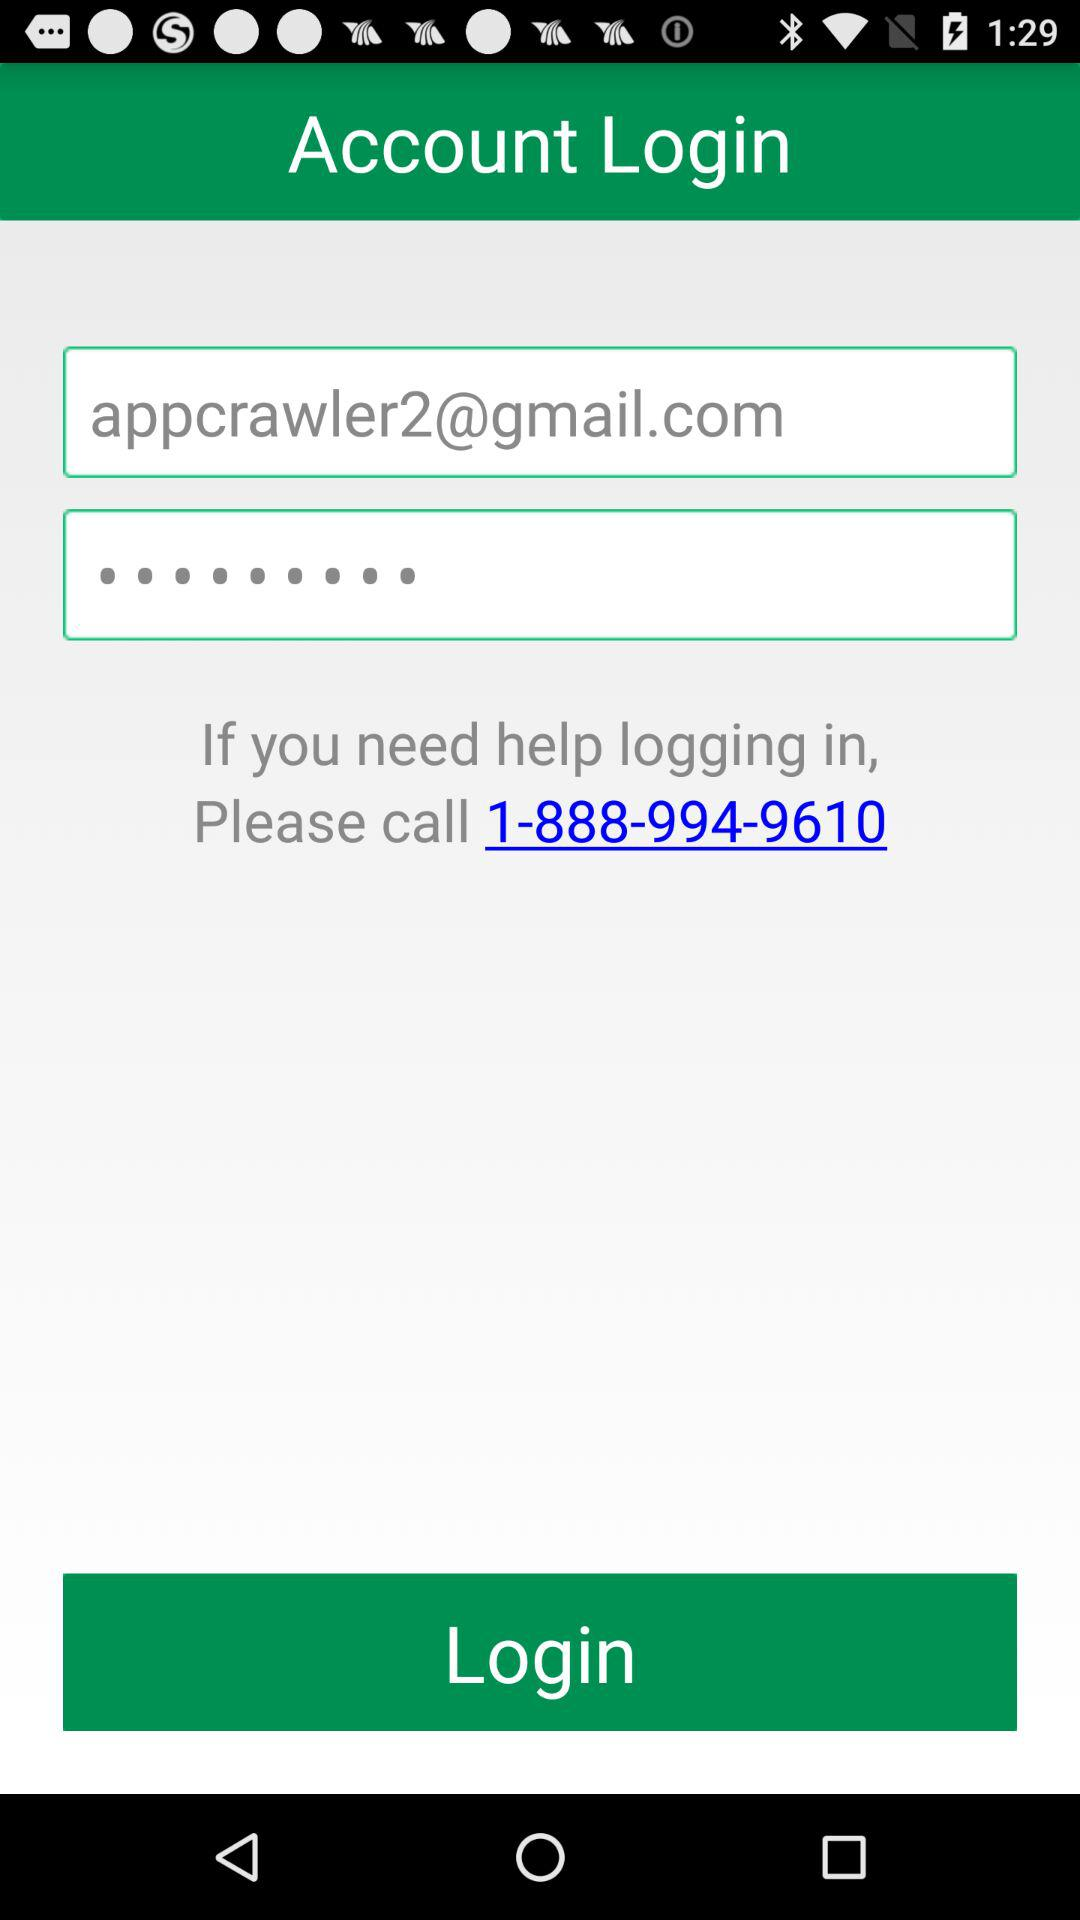What is the helpline phone number given? The helpline phone number given is 1-888-994-9610. 